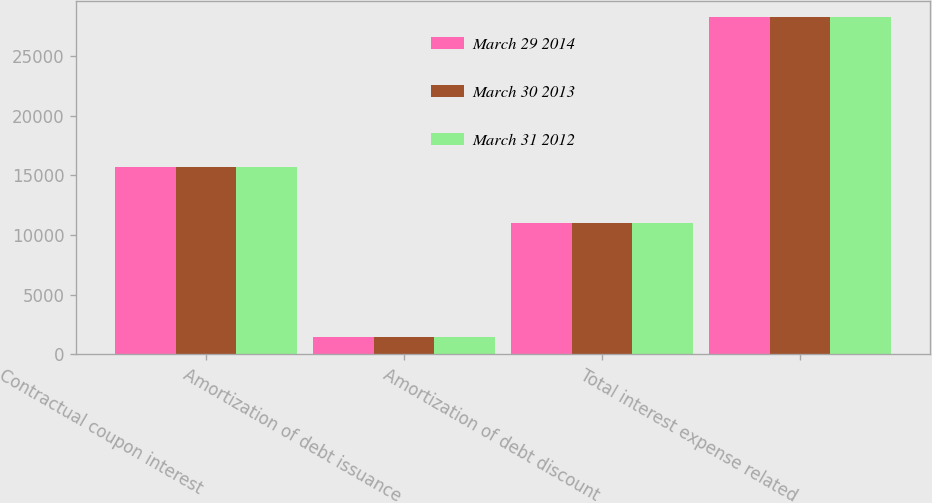<chart> <loc_0><loc_0><loc_500><loc_500><stacked_bar_chart><ecel><fcel>Contractual coupon interest<fcel>Amortization of debt issuance<fcel>Amortization of debt discount<fcel>Total interest expense related<nl><fcel>March 29 2014<fcel>15750<fcel>1448<fcel>11052<fcel>28250<nl><fcel>March 30 2013<fcel>15750<fcel>1448<fcel>11052<fcel>28250<nl><fcel>March 31 2012<fcel>15750<fcel>1448<fcel>11052<fcel>28250<nl></chart> 